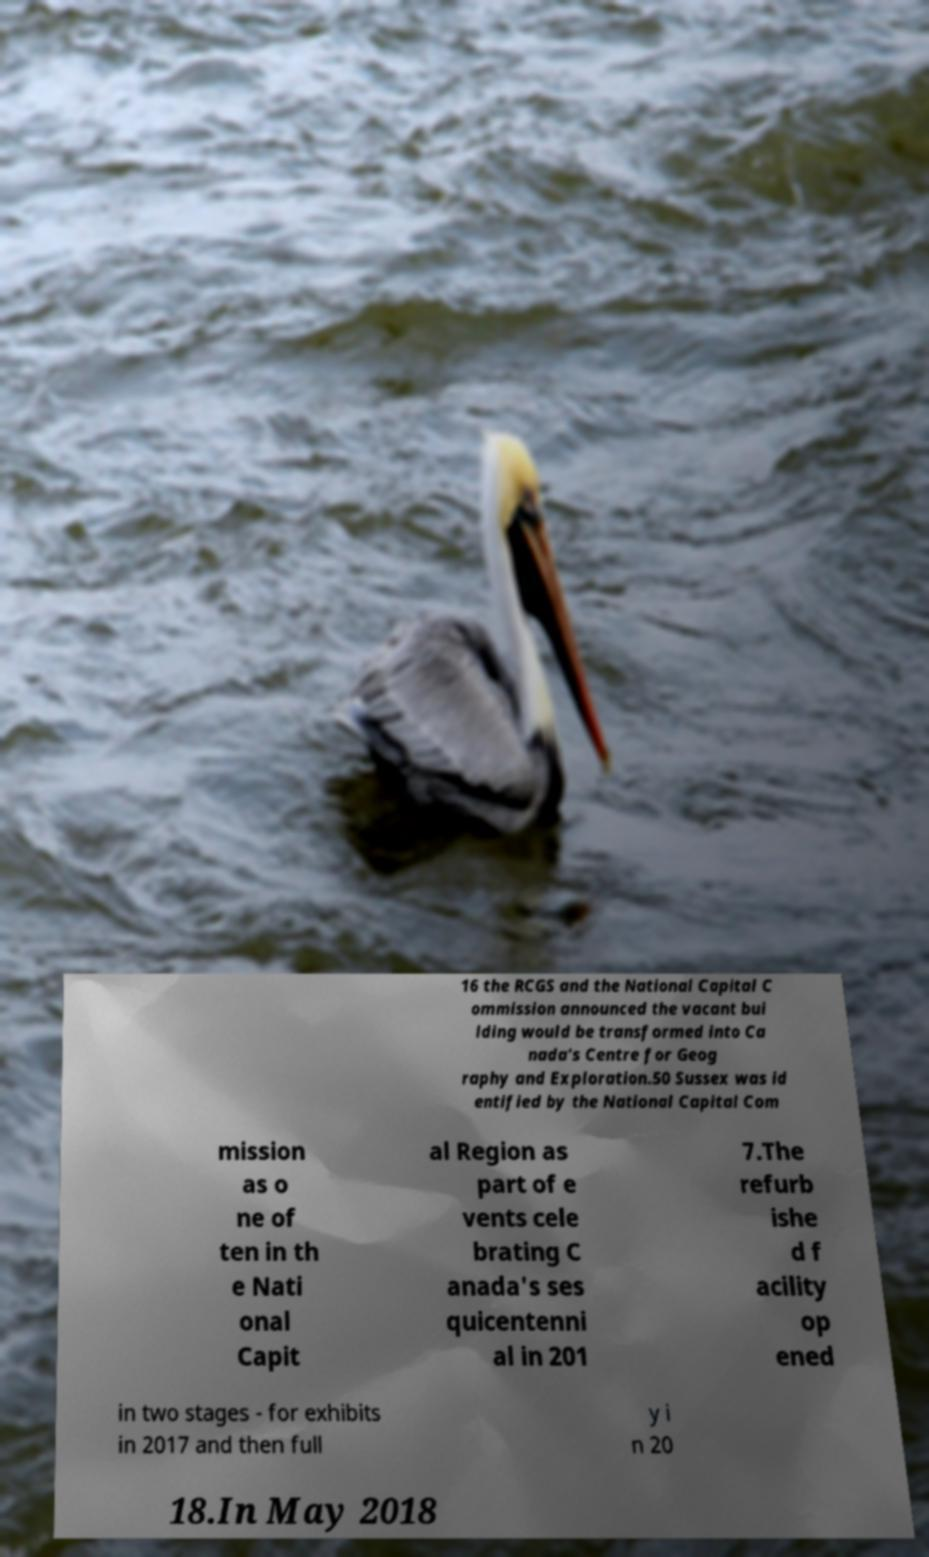I need the written content from this picture converted into text. Can you do that? 16 the RCGS and the National Capital C ommission announced the vacant bui lding would be transformed into Ca nada's Centre for Geog raphy and Exploration.50 Sussex was id entified by the National Capital Com mission as o ne of ten in th e Nati onal Capit al Region as part of e vents cele brating C anada's ses quicentenni al in 201 7.The refurb ishe d f acility op ened in two stages - for exhibits in 2017 and then full y i n 20 18.In May 2018 